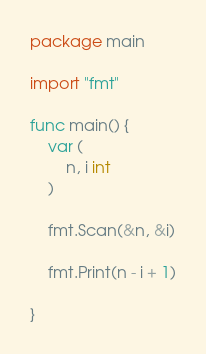Convert code to text. <code><loc_0><loc_0><loc_500><loc_500><_Go_>package main

import "fmt"

func main() {
	var (
		n, i int
	)

	fmt.Scan(&n, &i)

	fmt.Print(n - i + 1)

}
</code> 